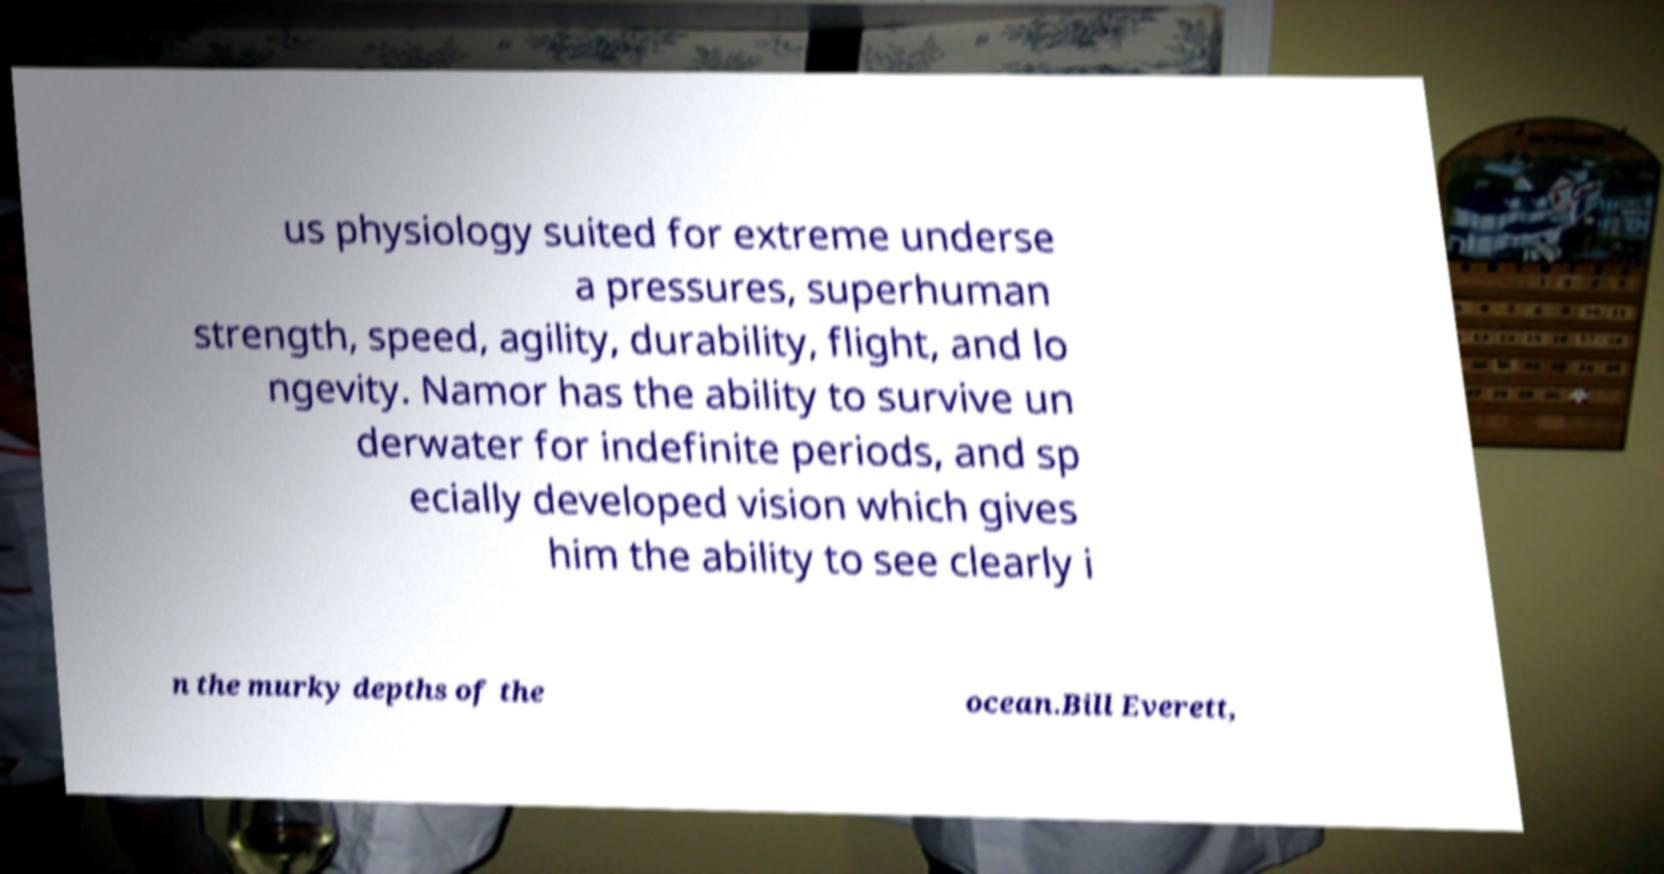Could you extract and type out the text from this image? us physiology suited for extreme underse a pressures, superhuman strength, speed, agility, durability, flight, and lo ngevity. Namor has the ability to survive un derwater for indefinite periods, and sp ecially developed vision which gives him the ability to see clearly i n the murky depths of the ocean.Bill Everett, 